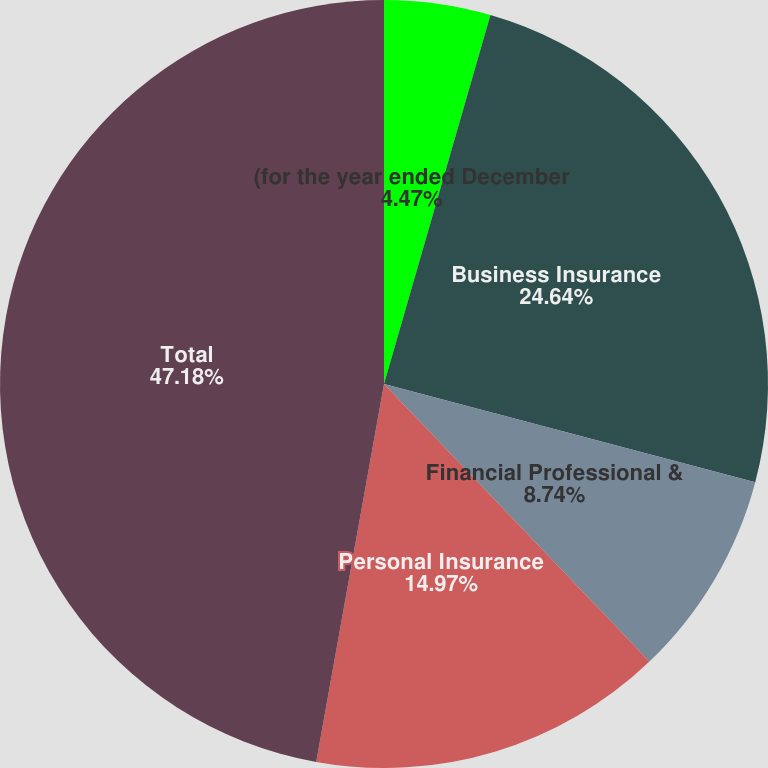Convert chart. <chart><loc_0><loc_0><loc_500><loc_500><pie_chart><fcel>(for the year ended December<fcel>Business Insurance<fcel>Financial Professional &<fcel>Personal Insurance<fcel>Total<nl><fcel>4.47%<fcel>24.64%<fcel>8.74%<fcel>14.97%<fcel>47.17%<nl></chart> 